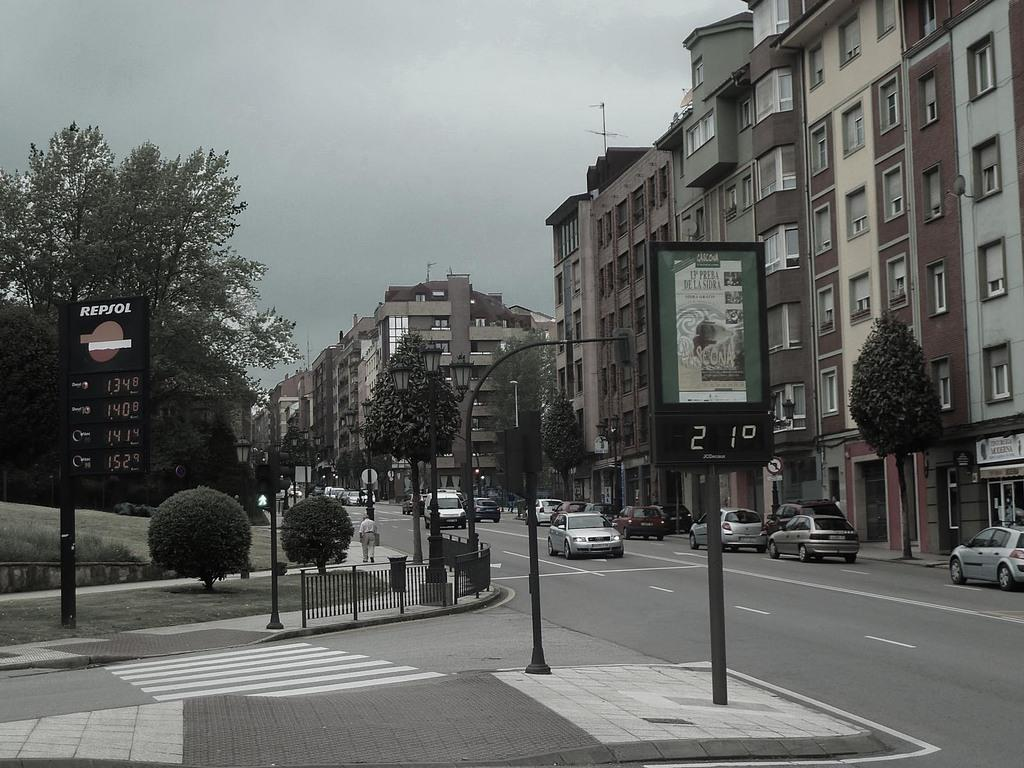Provide a one-sentence caption for the provided image. An urban street setting with a sign for Repsol in the corner. 